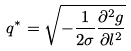<formula> <loc_0><loc_0><loc_500><loc_500>q ^ { * } = \sqrt { - \frac { 1 } { 2 \sigma } \frac { \partial ^ { 2 } g } { \partial l ^ { 2 } } }</formula> 